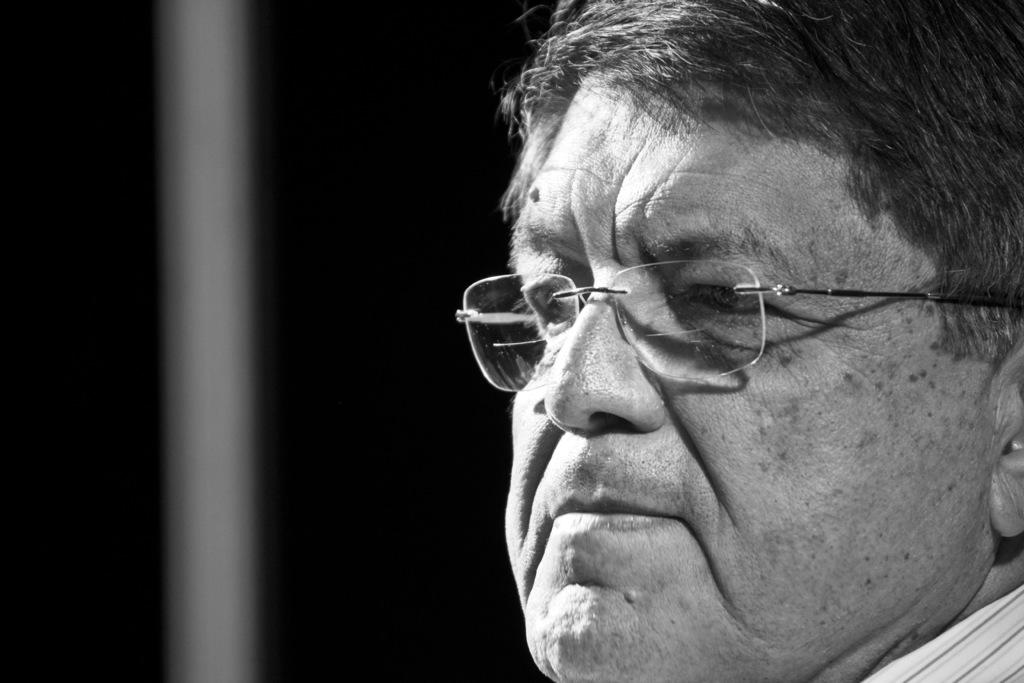What is the color scheme of the image? The image is black and white. What can be seen in the image? There is a person's face in the image in the image. What is the color of the background in the image? The background of the image is black. How many frogs are sitting on the person's shoulder in the image? There are no frogs present in the image. What does the person's grandmother say about the image? The image does not include any information about the person's grandmother, so it is not possible to answer this question. 